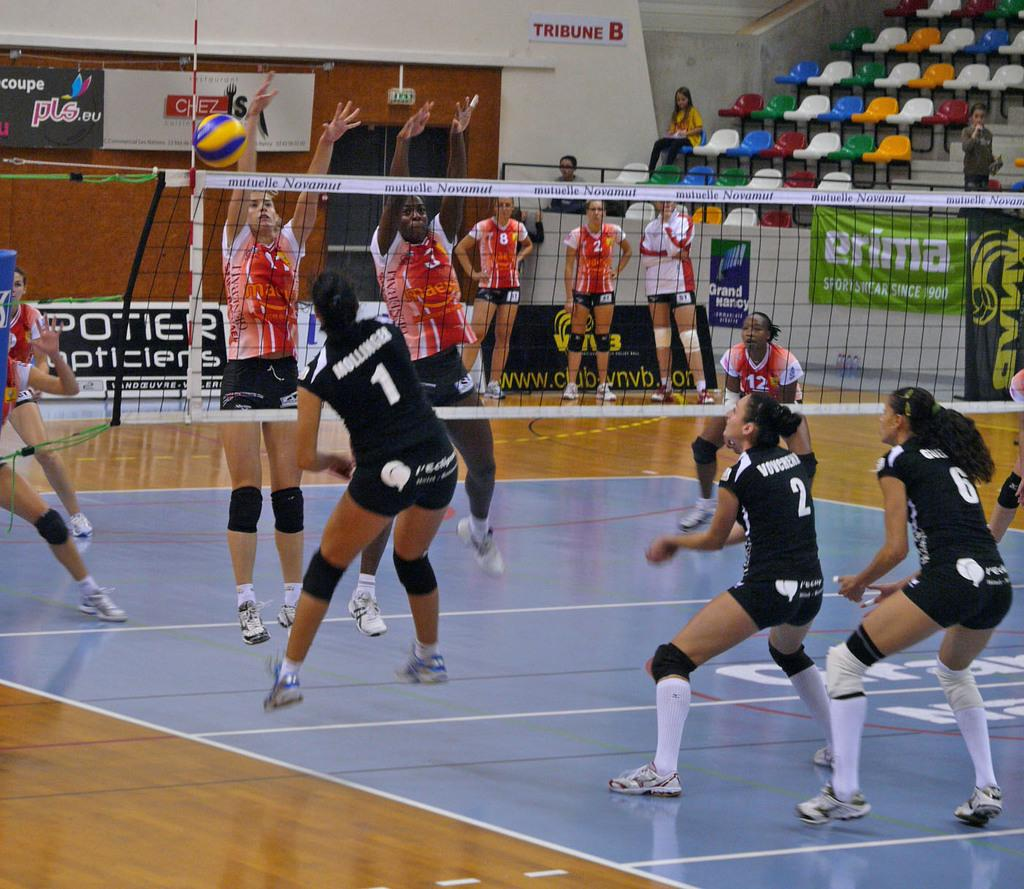<image>
Summarize the visual content of the image. a game of volleyball between girls with one of the adverts saying Prima on it. 